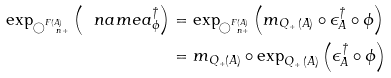<formula> <loc_0><loc_0><loc_500><loc_500>\exp _ { \bigcirc _ { \ n + } ^ { F ( A ) } } \left ( \ n a m e { a _ { \phi } ^ { \dag } } \right ) & = \exp _ { \bigcirc _ { \ n + } ^ { F ( A ) } } \left ( m _ { Q _ { + } \, ( A ) } \circ \epsilon ^ { \dag } _ { A } \circ \phi \right ) \\ & = m _ { Q _ { + } ( A ) } \circ \exp _ { Q _ { + } \, ( A ) } \left ( \epsilon _ { A } ^ { \dag } \circ \phi \right )</formula> 